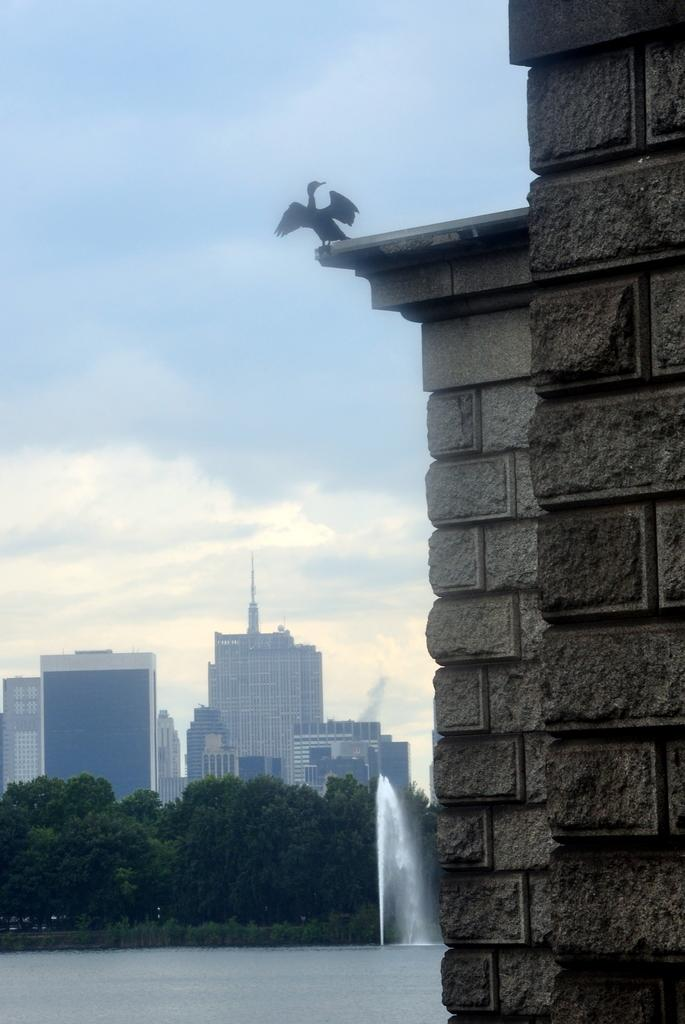What is the main structure in the picture? There is a building in the picture. What type of animal can be seen in the picture? There is a bird in the picture. What natural feature is visible in the backdrop of the picture? There is a lake in the backdrop of the picture. What architectural feature is visible in the backdrop of the picture? There is a fountain in the backdrop of the picture. What type of vegetation is visible in the backdrop of the picture? There are trees in the backdrop of the picture. What else can be seen in the backdrop of the picture? There are buildings in the backdrop of the picture. What is the condition of the sky in the backdrop of the picture? The sky is clear in the backdrop of the picture. What type of flower is being recorded in the picture? There is no flower or recording device present in the picture. 